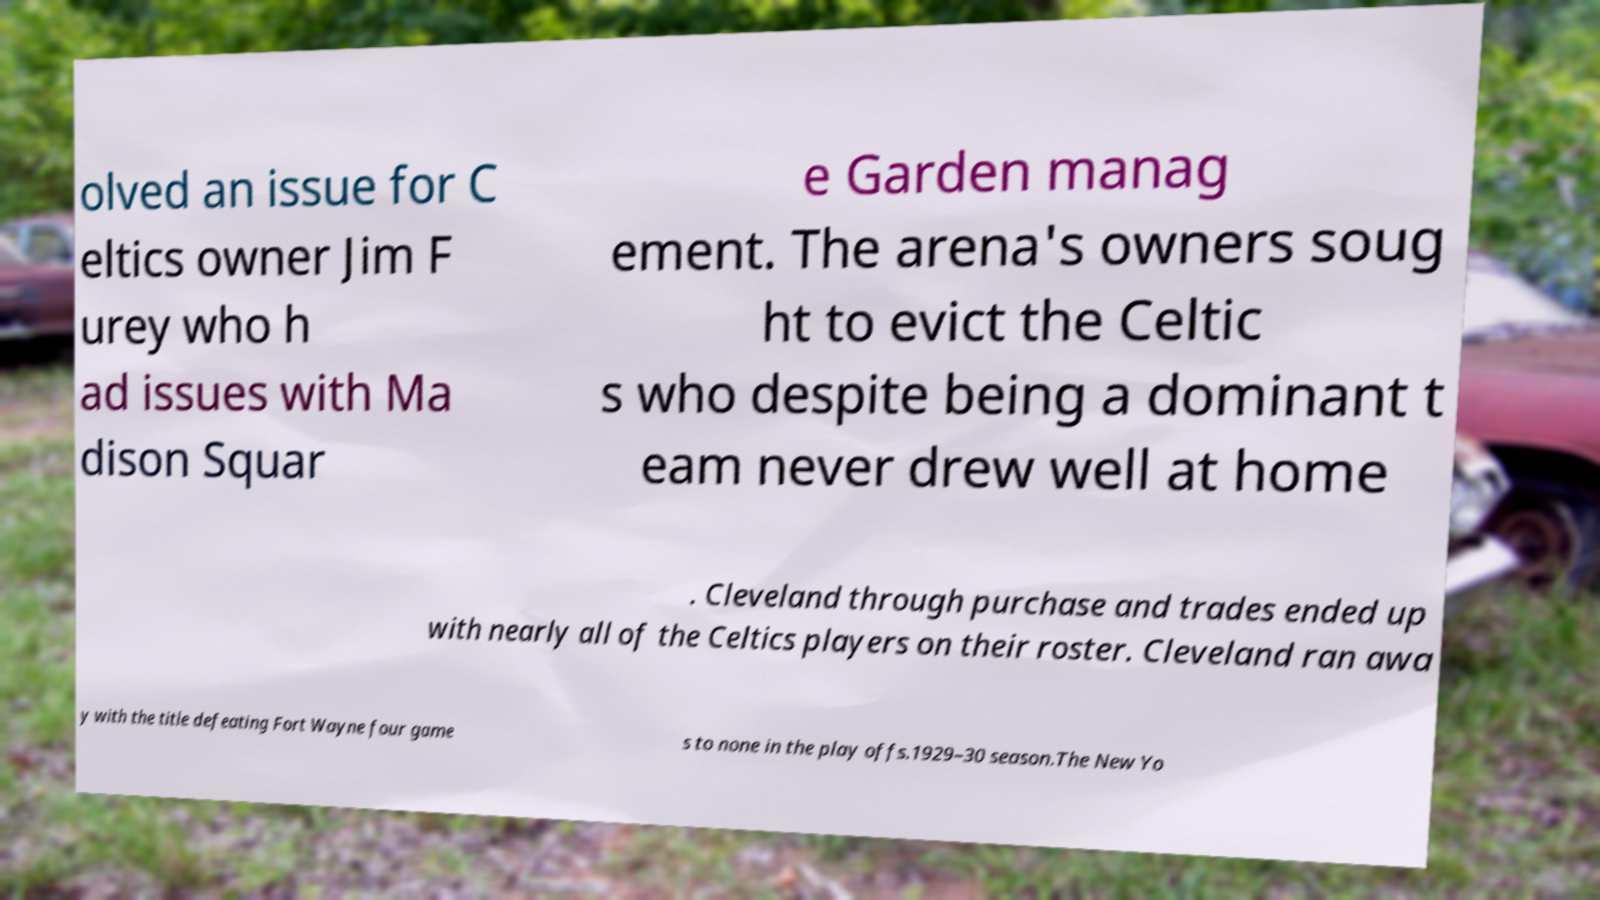What messages or text are displayed in this image? I need them in a readable, typed format. olved an issue for C eltics owner Jim F urey who h ad issues with Ma dison Squar e Garden manag ement. The arena's owners soug ht to evict the Celtic s who despite being a dominant t eam never drew well at home . Cleveland through purchase and trades ended up with nearly all of the Celtics players on their roster. Cleveland ran awa y with the title defeating Fort Wayne four game s to none in the play offs.1929–30 season.The New Yo 